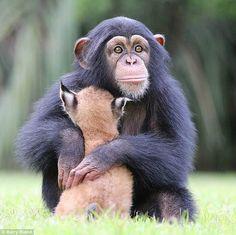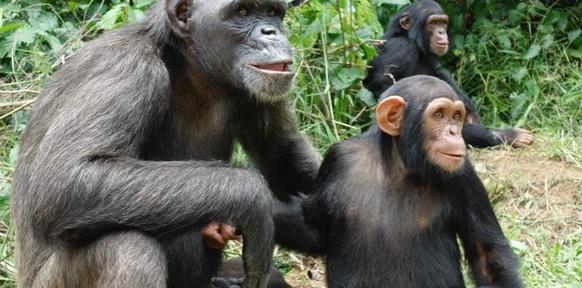The first image is the image on the left, the second image is the image on the right. Considering the images on both sides, is "There are a total of 5 monkeys present outside." valid? Answer yes or no. No. The first image is the image on the left, the second image is the image on the right. Considering the images on both sides, is "In one image there is a single chimpanzee and in the other there is a group of at least four." valid? Answer yes or no. No. 